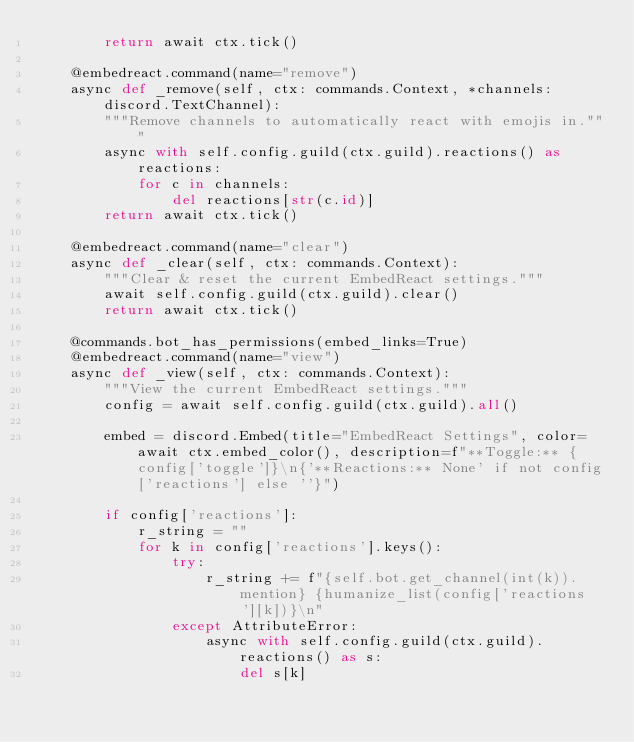Convert code to text. <code><loc_0><loc_0><loc_500><loc_500><_Python_>        return await ctx.tick()

    @embedreact.command(name="remove")
    async def _remove(self, ctx: commands.Context, *channels: discord.TextChannel):
        """Remove channels to automatically react with emojis in."""
        async with self.config.guild(ctx.guild).reactions() as reactions:
            for c in channels:
                del reactions[str(c.id)]
        return await ctx.tick()

    @embedreact.command(name="clear")
    async def _clear(self, ctx: commands.Context):
        """Clear & reset the current EmbedReact settings."""
        await self.config.guild(ctx.guild).clear()
        return await ctx.tick()

    @commands.bot_has_permissions(embed_links=True)
    @embedreact.command(name="view")
    async def _view(self, ctx: commands.Context):
        """View the current EmbedReact settings."""
        config = await self.config.guild(ctx.guild).all()

        embed = discord.Embed(title="EmbedReact Settings", color=await ctx.embed_color(), description=f"**Toggle:** {config['toggle']}\n{'**Reactions:** None' if not config['reactions'] else ''}")

        if config['reactions']:
            r_string = ""
            for k in config['reactions'].keys():
                try:
                    r_string += f"{self.bot.get_channel(int(k)).mention} {humanize_list(config['reactions'][k])}\n"
                except AttributeError:
                    async with self.config.guild(ctx.guild).reactions() as s:
                        del s[k]</code> 